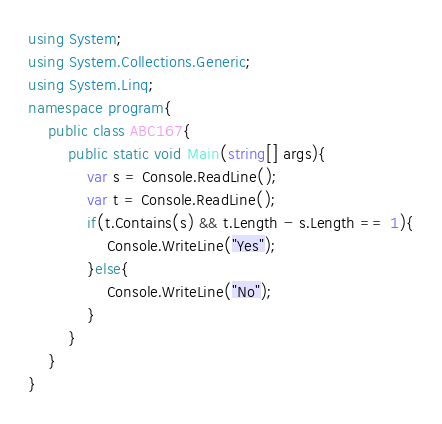<code> <loc_0><loc_0><loc_500><loc_500><_C#_>using System;
using System.Collections.Generic;
using System.Linq;
namespace program{
    public class ABC167{
        public static void Main(string[] args){
            var s = Console.ReadLine();
            var t = Console.ReadLine();
            if(t.Contains(s) && t.Length - s.Length == 1){
                Console.WriteLine("Yes");
            }else{
                Console.WriteLine("No");
            }
        }
    }
}
</code> 